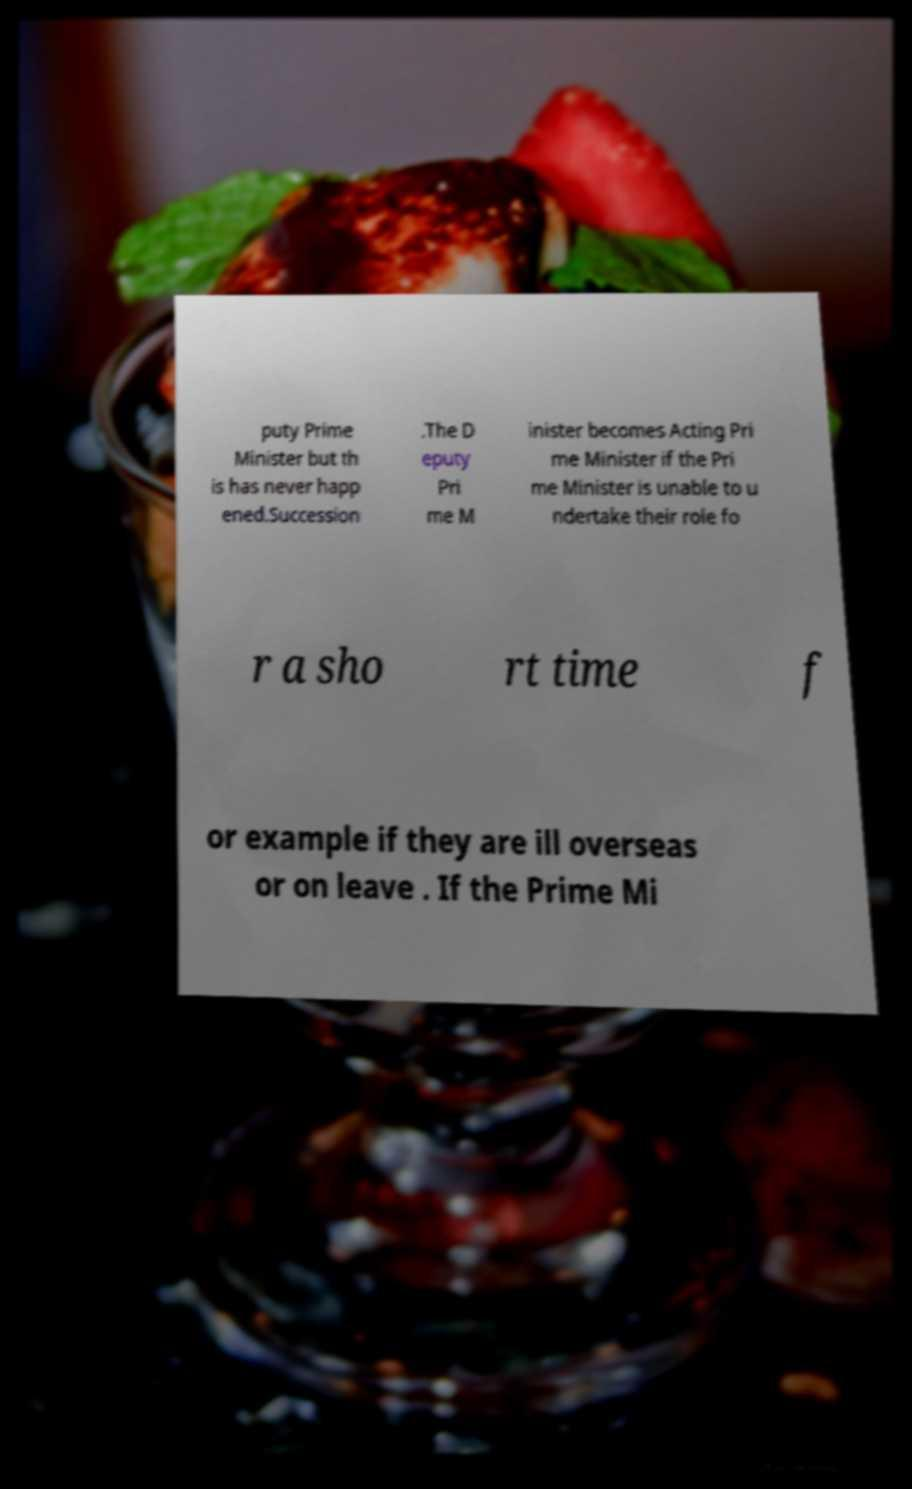Please identify and transcribe the text found in this image. puty Prime Minister but th is has never happ ened.Succession .The D eputy Pri me M inister becomes Acting Pri me Minister if the Pri me Minister is unable to u ndertake their role fo r a sho rt time f or example if they are ill overseas or on leave . If the Prime Mi 